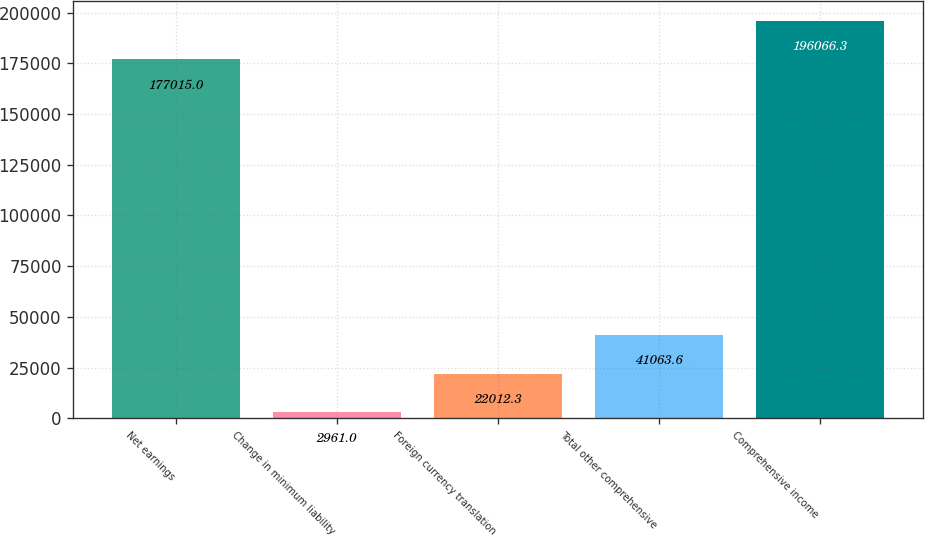Convert chart. <chart><loc_0><loc_0><loc_500><loc_500><bar_chart><fcel>Net earnings<fcel>Change in minimum liability<fcel>Foreign currency translation<fcel>Total other comprehensive<fcel>Comprehensive income<nl><fcel>177015<fcel>2961<fcel>22012.3<fcel>41063.6<fcel>196066<nl></chart> 